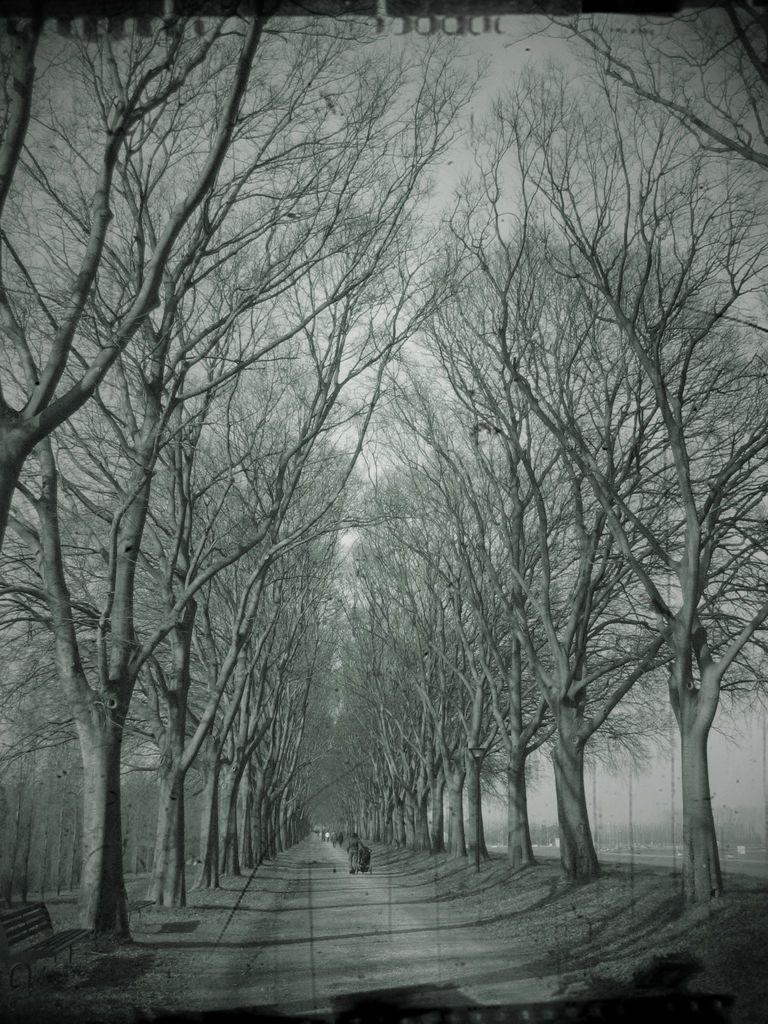How would you summarize this image in a sentence or two? In this image we can see walkway through which some persons are walking on left side of the image there is bench and there are some trees on left and right side of the image and in the background of the image there is clear sky. 